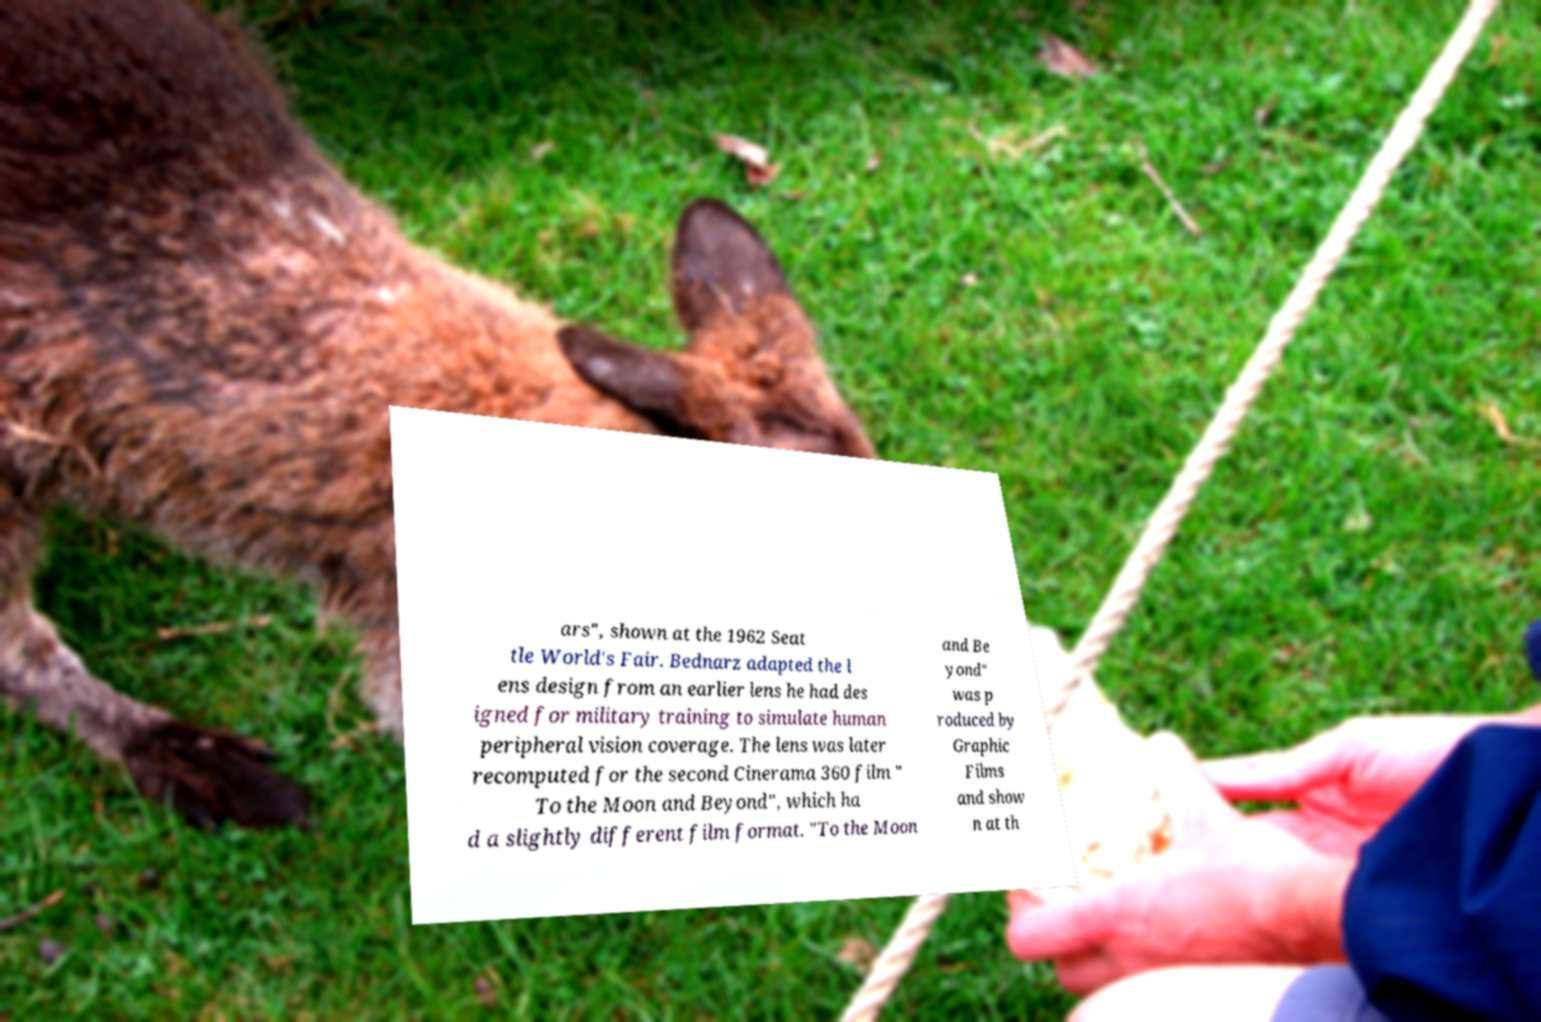For documentation purposes, I need the text within this image transcribed. Could you provide that? ars", shown at the 1962 Seat tle World's Fair. Bednarz adapted the l ens design from an earlier lens he had des igned for military training to simulate human peripheral vision coverage. The lens was later recomputed for the second Cinerama 360 film " To the Moon and Beyond", which ha d a slightly different film format. "To the Moon and Be yond" was p roduced by Graphic Films and show n at th 